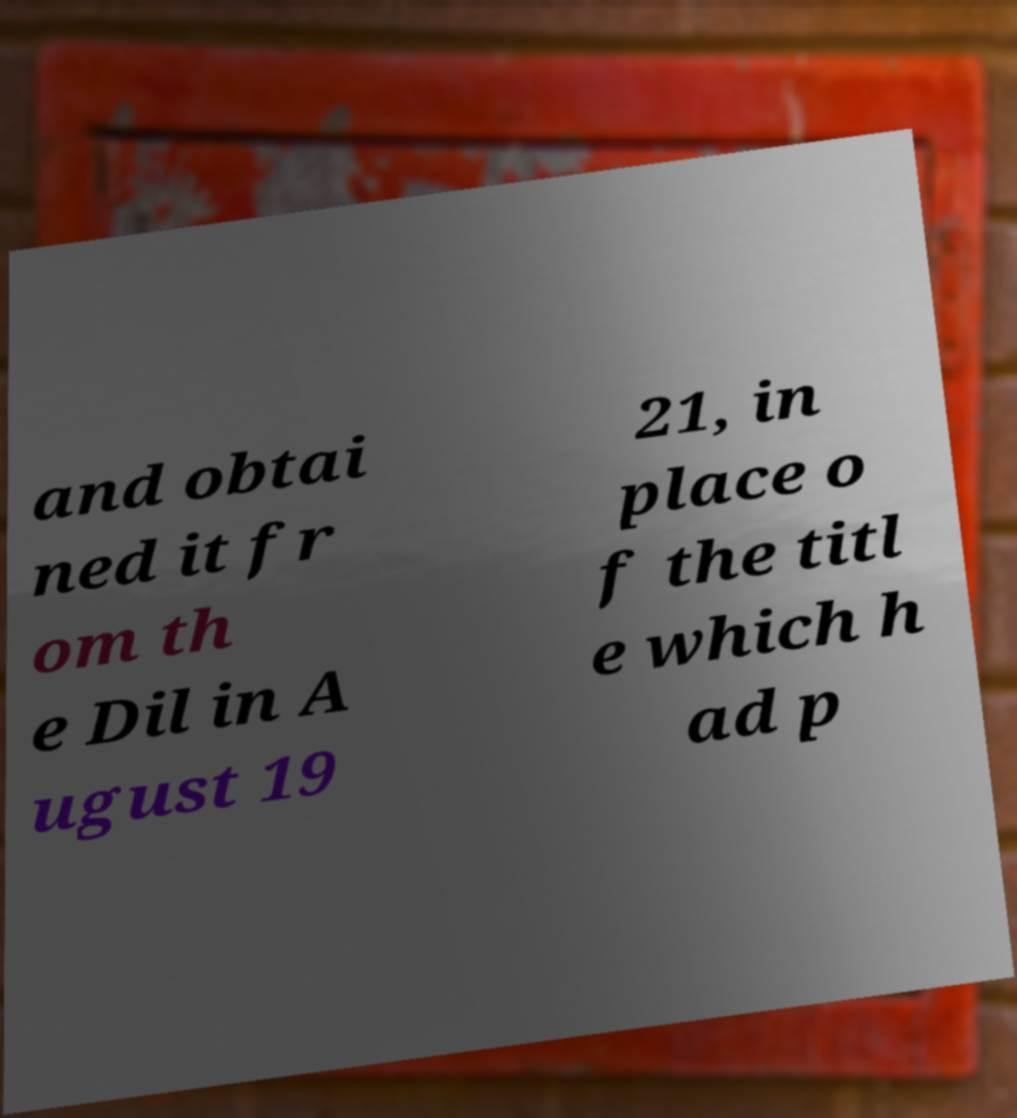Can you accurately transcribe the text from the provided image for me? and obtai ned it fr om th e Dil in A ugust 19 21, in place o f the titl e which h ad p 